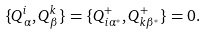Convert formula to latex. <formula><loc_0><loc_0><loc_500><loc_500>\{ Q _ { \alpha } ^ { i } , Q _ { \beta } ^ { k } \} = \{ Q _ { i \alpha ^ { * } } ^ { + } , Q _ { k \beta ^ { * } } ^ { + } \} = 0 .</formula> 